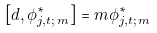Convert formula to latex. <formula><loc_0><loc_0><loc_500><loc_500>\left [ d , \phi ^ { * } _ { j , t ; \, m } \right ] = m \phi ^ { * } _ { j , t ; \, m }</formula> 